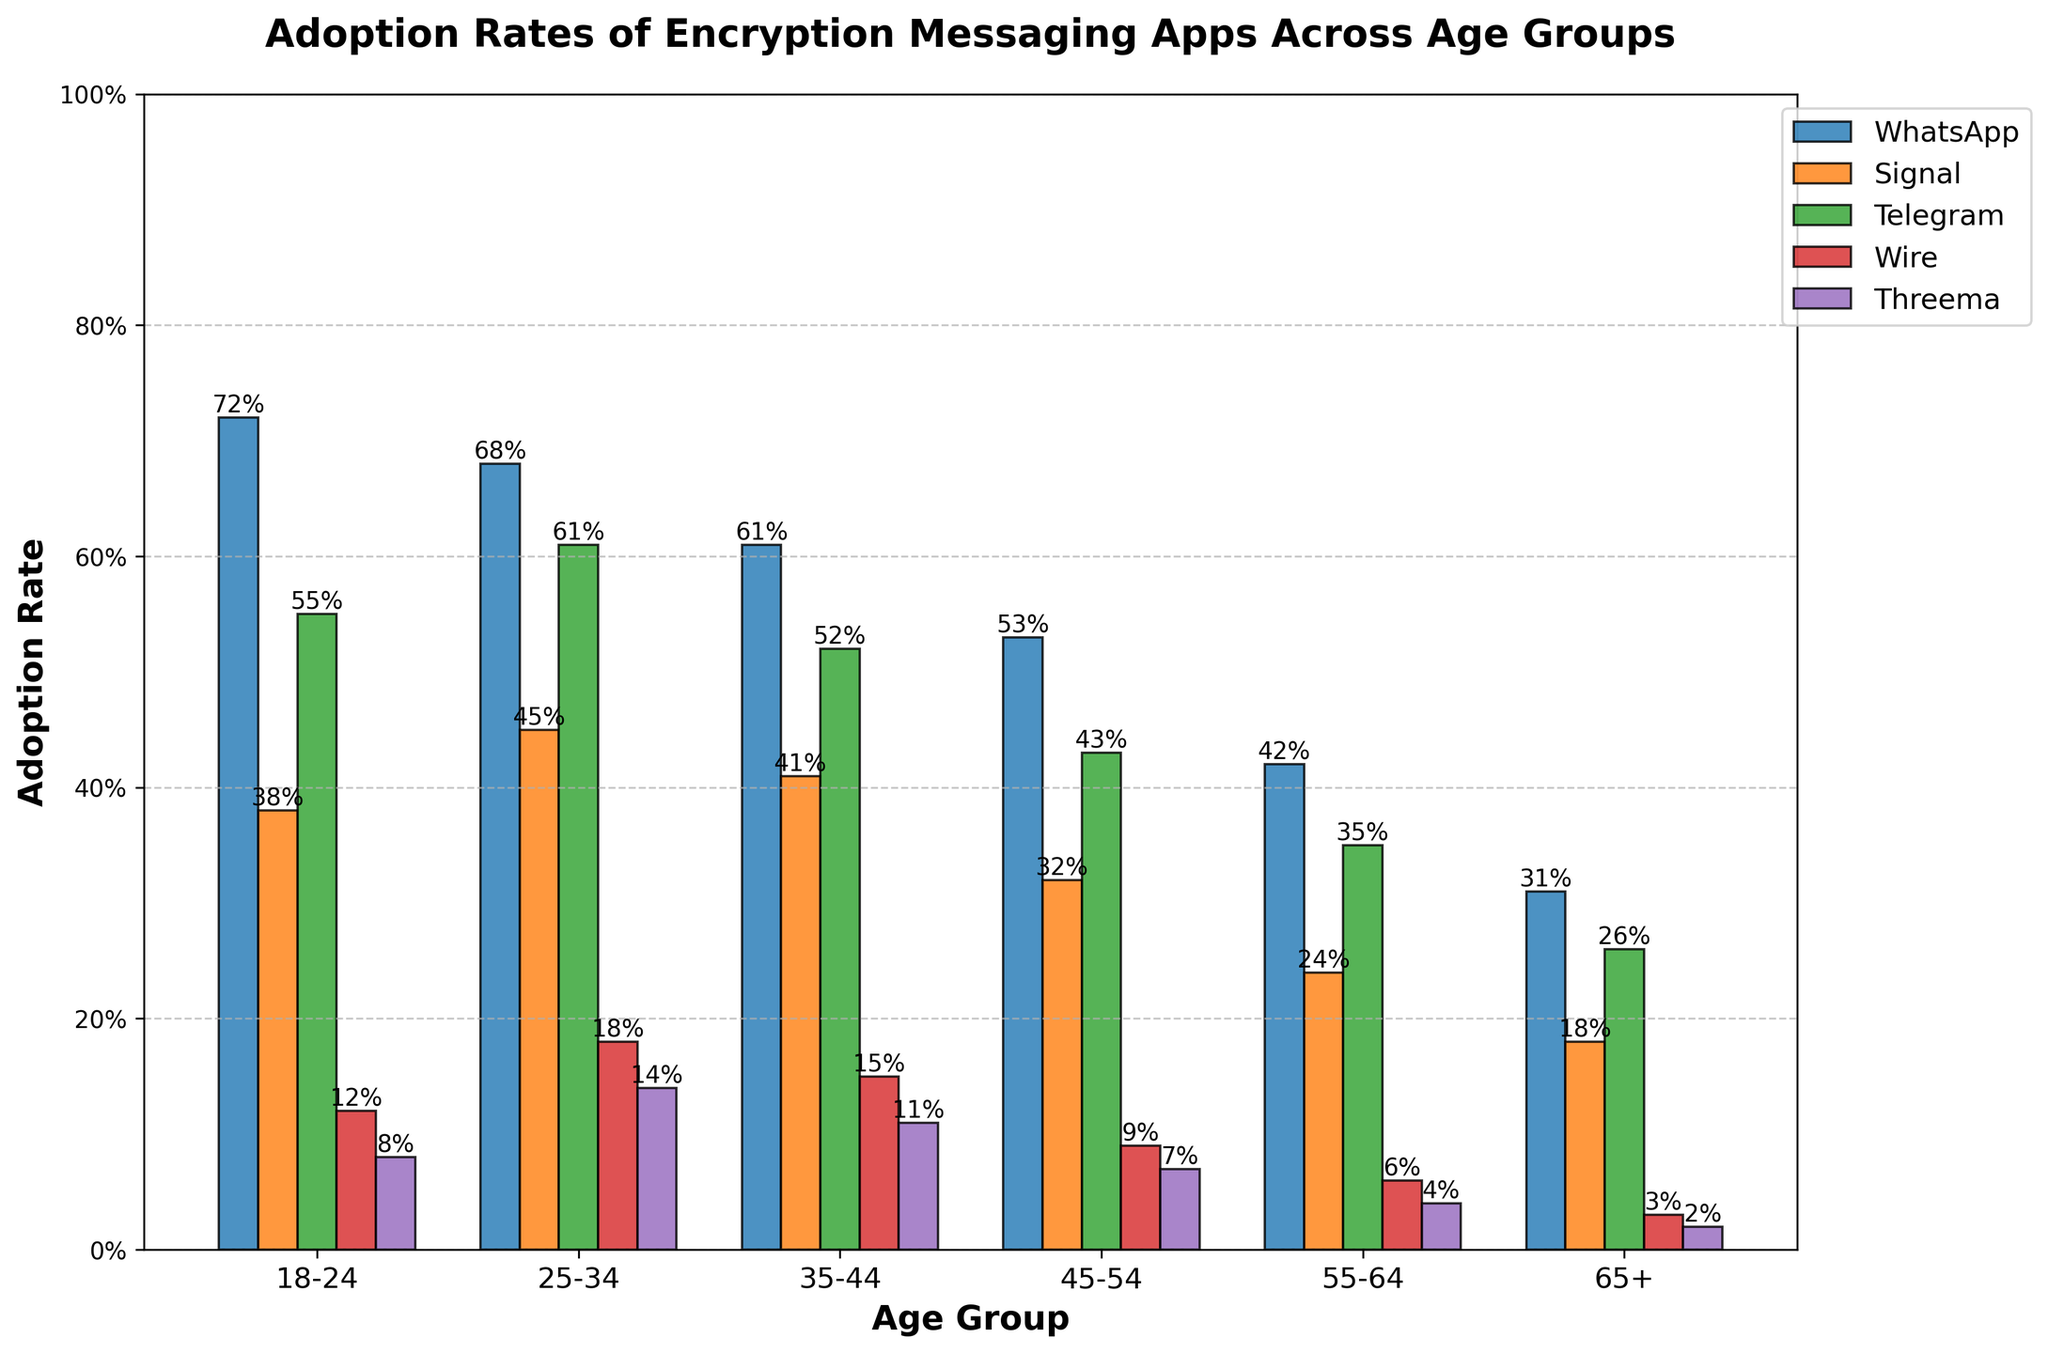What age group has the highest adoption rate of WhatsApp? The bar corresponding to the 18-24 age group is the tallest among the WhatsApp bars.
Answer: 18-24 Which app has the lowest adoption rate in the 65+ age group? Among the bars corresponding to the 65+ age group, Wire and Threema have the lowest height, with Threema being the shortest.
Answer: Threema What's the difference in adoption rates of Telegram between the 18-24 and 25-34 age groups? The height of the Telegram bar within the 18-24 group is at 55% and it is 61% for the 25-34 group. The difference is 61% - 55%.
Answer: 6% Among the apps, which one shows the most consistent adoption rate across different age groups? By examining the bars, Signal shows a relatively stable pattern across all age groups compared to other apps.
Answer: Signal How much greater is the adoption rate of Signal compared to Threema in the 25-34 age group? The bars corresponding to Signal and Threema in the 25-34 age group are at 45% and 14% respectively. The difference is 45% - 14%.
Answer: 31% What is the average adoption rate of Wire across all age groups? Adding up the percentages for Wire: 12% + 18% + 15% + 9% + 6% + 3% = 63%. Dividing by the number of groups (6), the average is 63%/6.
Answer: 10.5% Which age group has the smallest adoption rate difference between Telegram and WhatsApp? Calculating the difference for all age groups: 
18-24: 72%-55% = 17%, 
25-34: 68%-61% = 7%, 
35-44: 61%-52% = 9%, 
45-54: 53%-43% = 10%, 
55-64: 42%-35% = 7%, 
65+: 31%-26% = 5%. The 65+ group has the smallest difference of 5%.
Answer: 65+ In which age group does Threema show the highest adoption rate? Observing the bars for Threema, the 25-34 age group has the highest bar at 14%.
Answer: 25-34 How does the adoption rate of Wire in the 18-24 age group compare to the overall average adoption rate of Wire? The adoption rate for Wire in the 18-24 age group is 12%. The overall average adoption rate of Wire is 10.5%. Since 12% > 10.5%, the adoption rate is higher.
Answer: Higher 